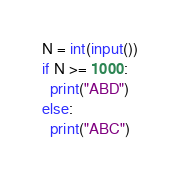Convert code to text. <code><loc_0><loc_0><loc_500><loc_500><_Python_>N = int(input())
if N >= 1000:
  print("ABD")
else:
  print("ABC")</code> 